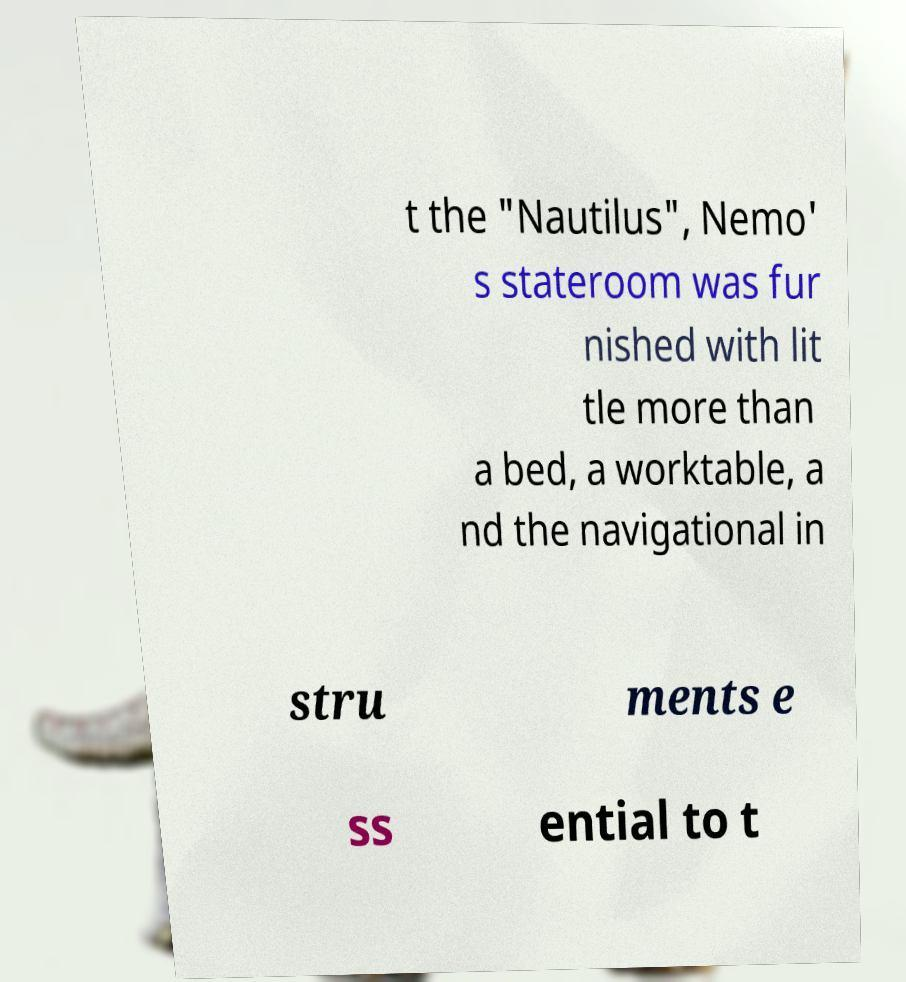Can you accurately transcribe the text from the provided image for me? t the "Nautilus", Nemo' s stateroom was fur nished with lit tle more than a bed, a worktable, a nd the navigational in stru ments e ss ential to t 